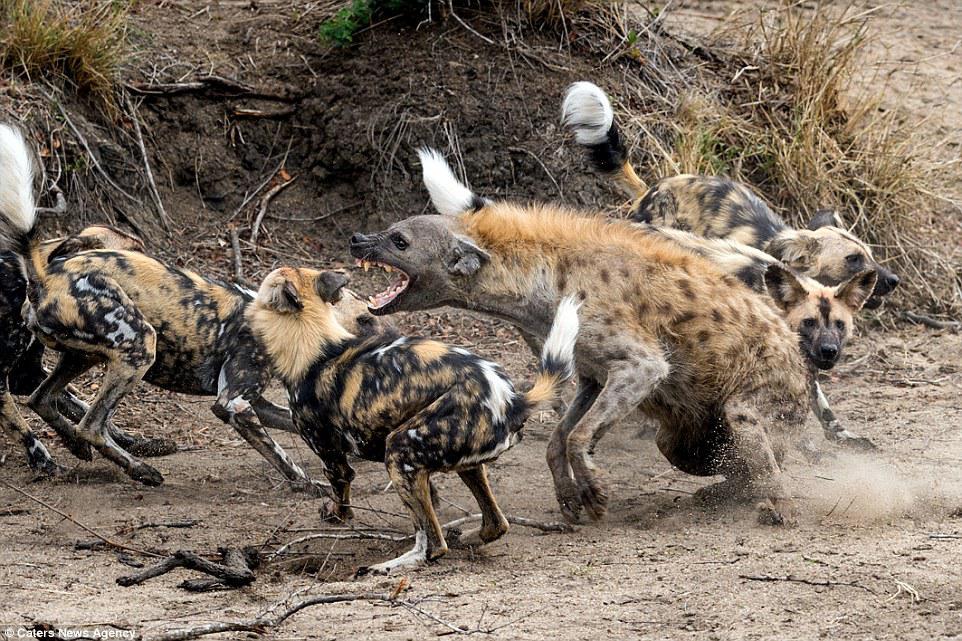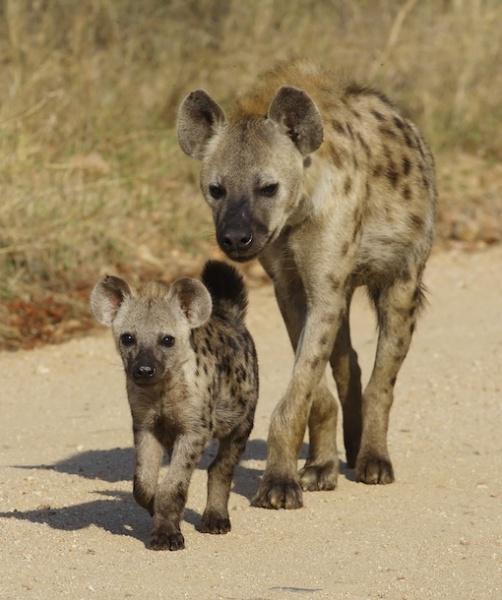The first image is the image on the left, the second image is the image on the right. For the images shown, is this caption "The lefthand image contains a single hyena, and the right image contains at least four hyena." true? Answer yes or no. No. 